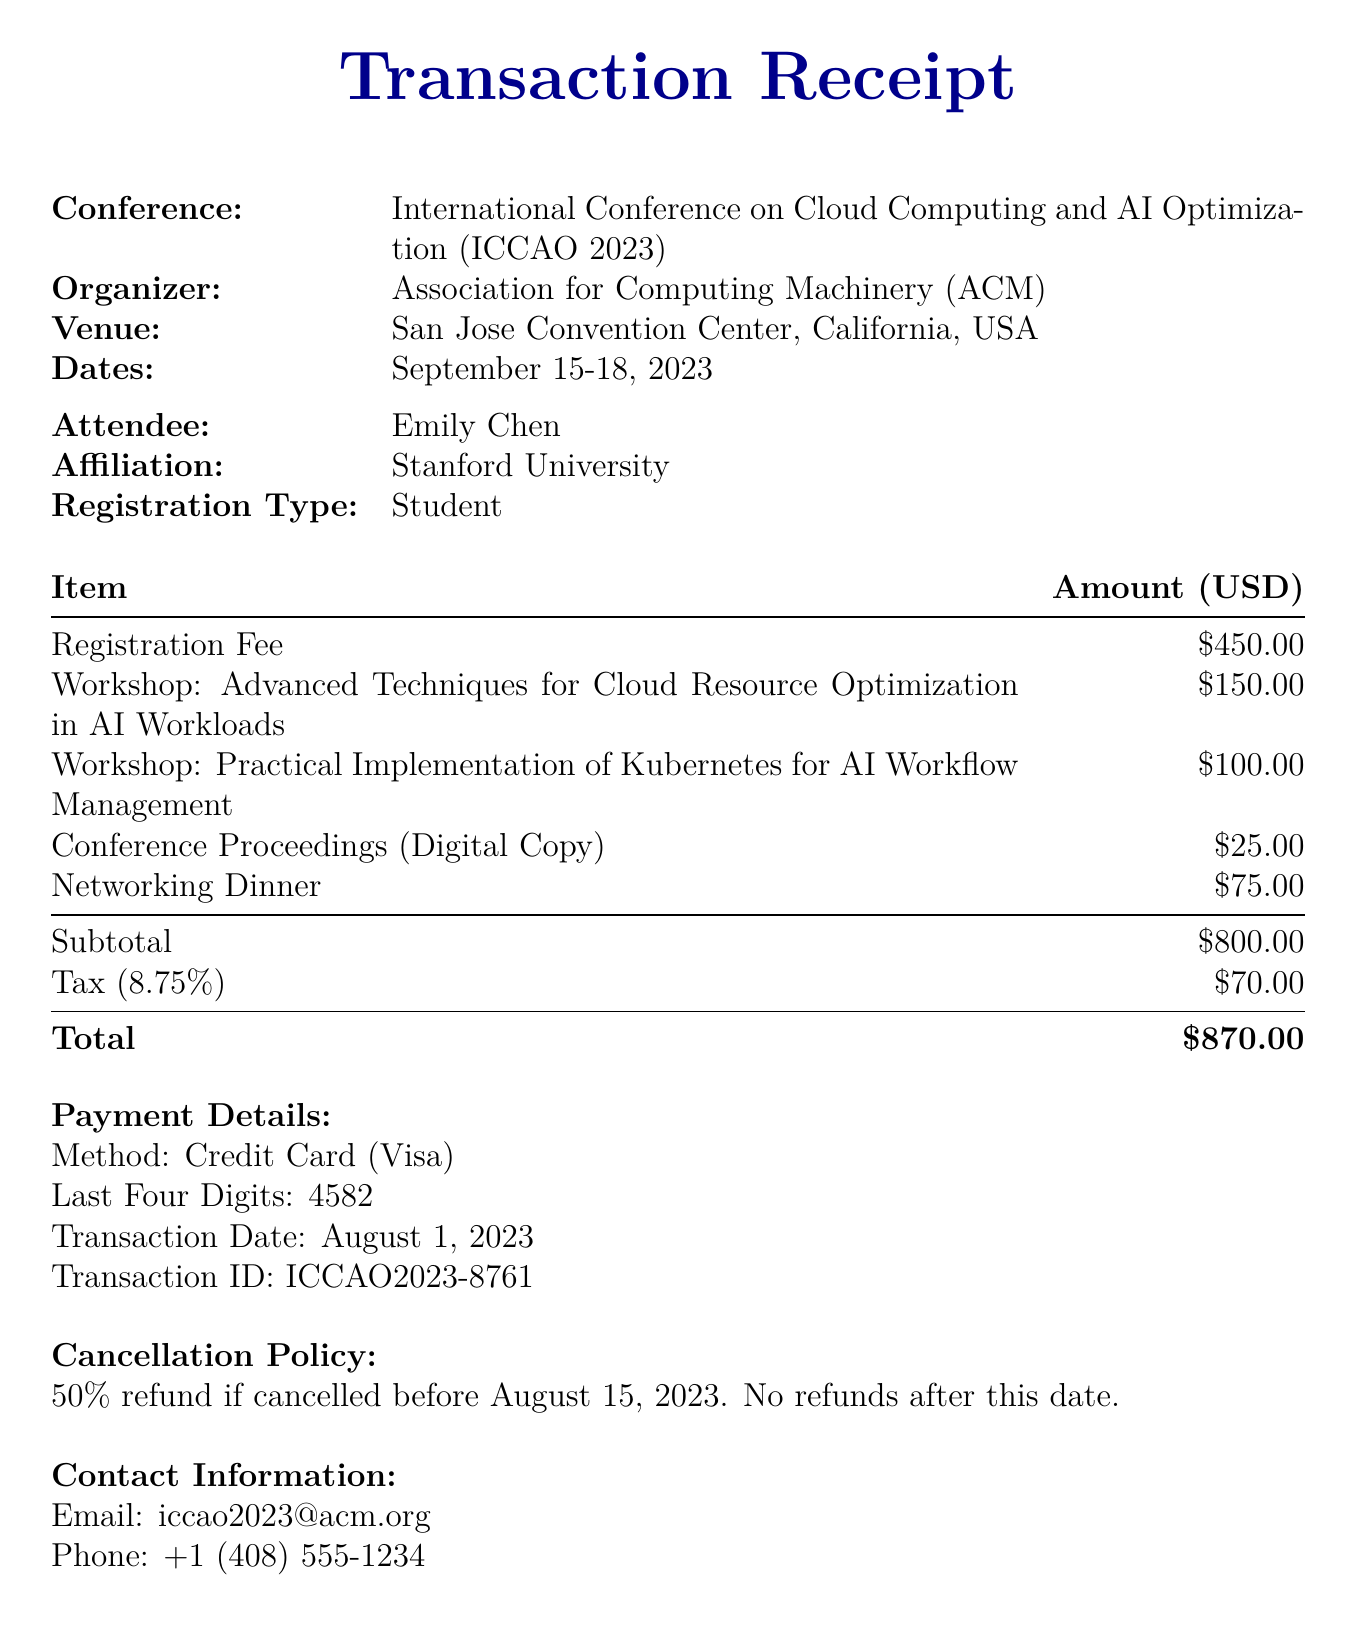What is the conference name? The conference name is specifically stated in the document as the title of the event.
Answer: International Conference on Cloud Computing and AI Optimization (ICCAO 2023) Who is the organizer of the conference? The organizer is mentioned directly in the document under the organizer section.
Answer: Association for Computing Machinery (ACM) What is the total amount paid for the registration? The total amount is clearly indicated at the bottom of the itemized costs section in the document.
Answer: $870.00 What is the duration of the workshop on cloud resource optimization? The duration is mentioned in the workshop details, which is a specific characteristic of that session.
Answer: Full-day What is the fee for the workshop on Kubernetes? This fee is listed in the workshop details in the document, providing a clear monetary figure.
Answer: $100.00 When is the conference scheduled to take place? The dates are outlined at the beginning of the document, summarizing the conference timeline.
Answer: September 15-18, 2023 What payment method was used for the registration? The payment method section specifies how the payment was processed.
Answer: Credit Card What is the cancellation policy for the registration? The cancellation policy is explicitly stated in the document, outlining refund conditions.
Answer: 50% refund if cancelled before August 15, 2023. No refunds after this date Who is instructing the workshop on cloud resource optimization? The instructor's name is provided alongside the workshop details, which is important for attendees.
Answer: Dr. Rajesh Gupta, Google Cloud AI What is the email contact for the conference organizers? The contact information section provides the email address for inquiries.
Answer: iccao2023@acm.org 